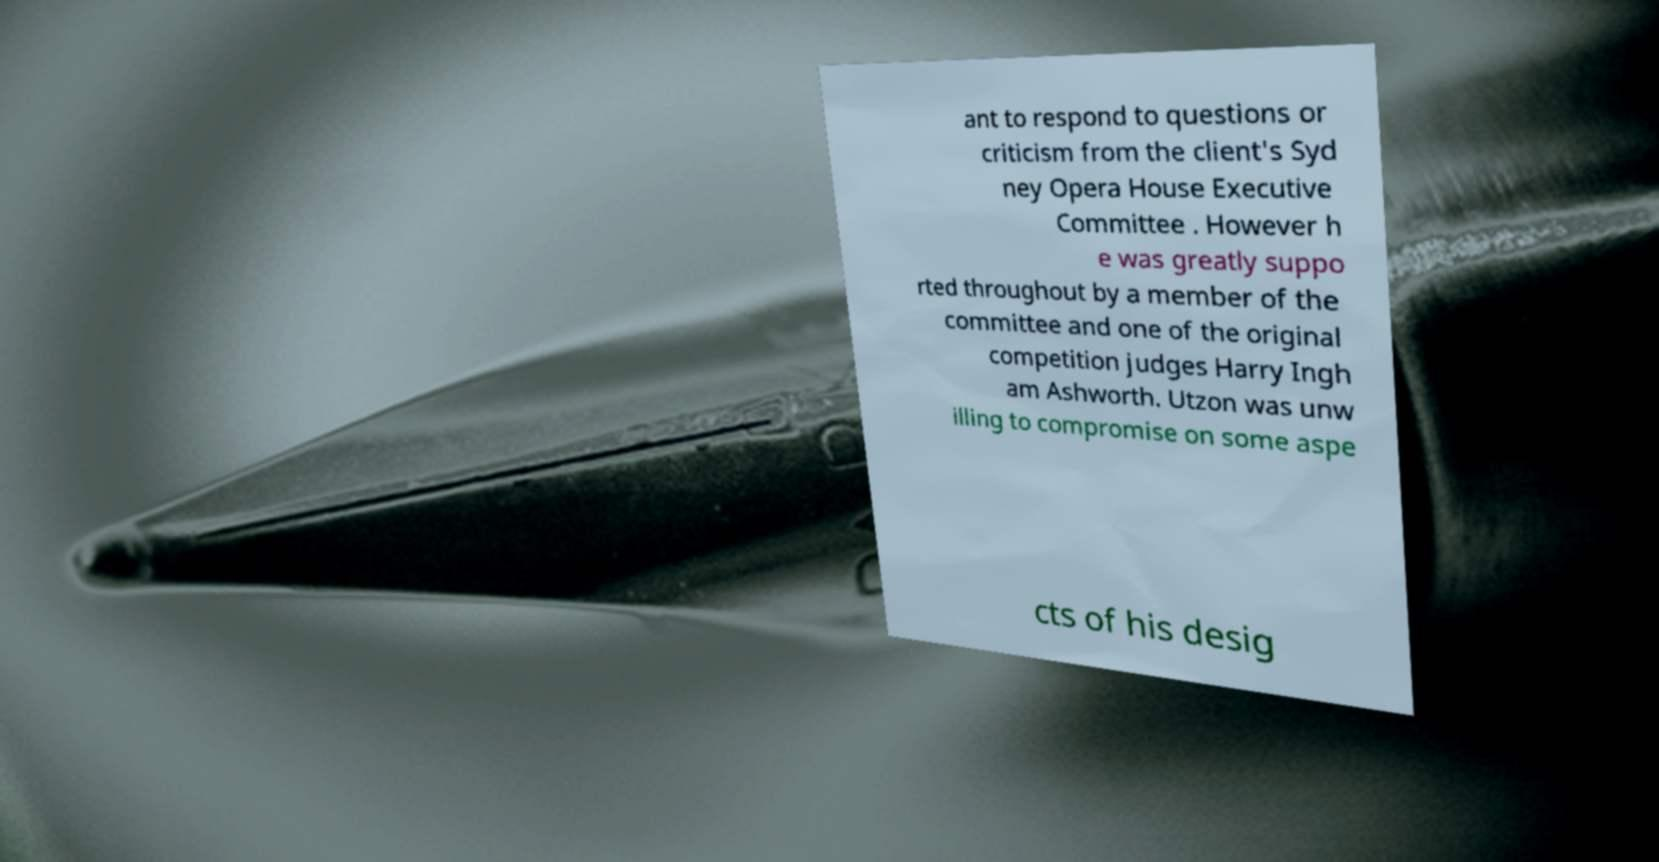Could you extract and type out the text from this image? ant to respond to questions or criticism from the client's Syd ney Opera House Executive Committee . However h e was greatly suppo rted throughout by a member of the committee and one of the original competition judges Harry Ingh am Ashworth. Utzon was unw illing to compromise on some aspe cts of his desig 